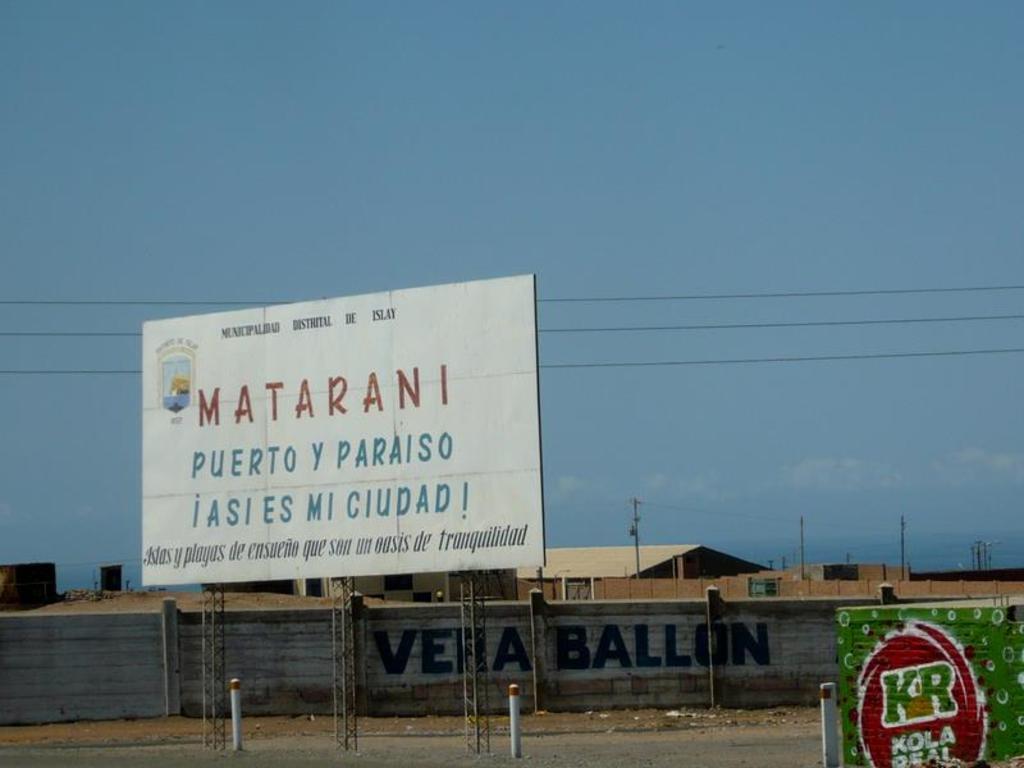What is the name written in red on the billboard?
Your answer should be compact. Matarani. What two letters are written in green on the green sign?
Your response must be concise. Kr. 